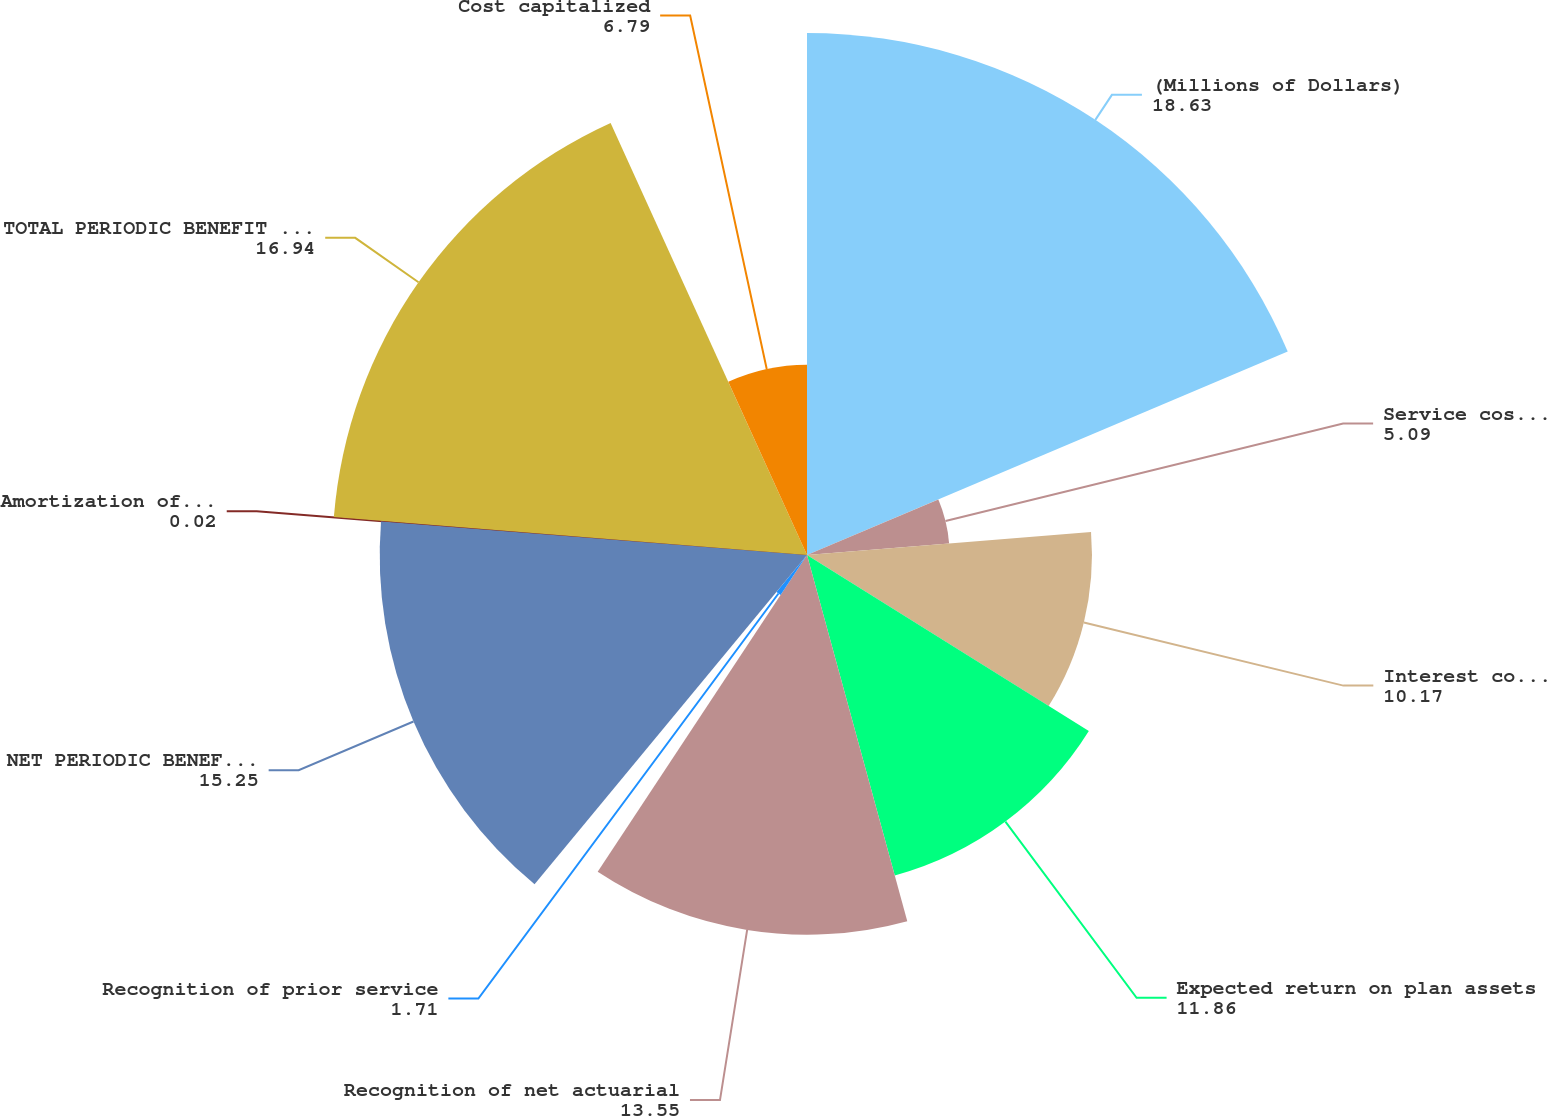Convert chart. <chart><loc_0><loc_0><loc_500><loc_500><pie_chart><fcel>(Millions of Dollars)<fcel>Service cost - including<fcel>Interest cost on projected<fcel>Expected return on plan assets<fcel>Recognition of net actuarial<fcel>Recognition of prior service<fcel>NET PERIODIC BENEFIT COST<fcel>Amortization of regulatory<fcel>TOTAL PERIODIC BENEFIT COST<fcel>Cost capitalized<nl><fcel>18.63%<fcel>5.09%<fcel>10.17%<fcel>11.86%<fcel>13.55%<fcel>1.71%<fcel>15.25%<fcel>0.02%<fcel>16.94%<fcel>6.79%<nl></chart> 